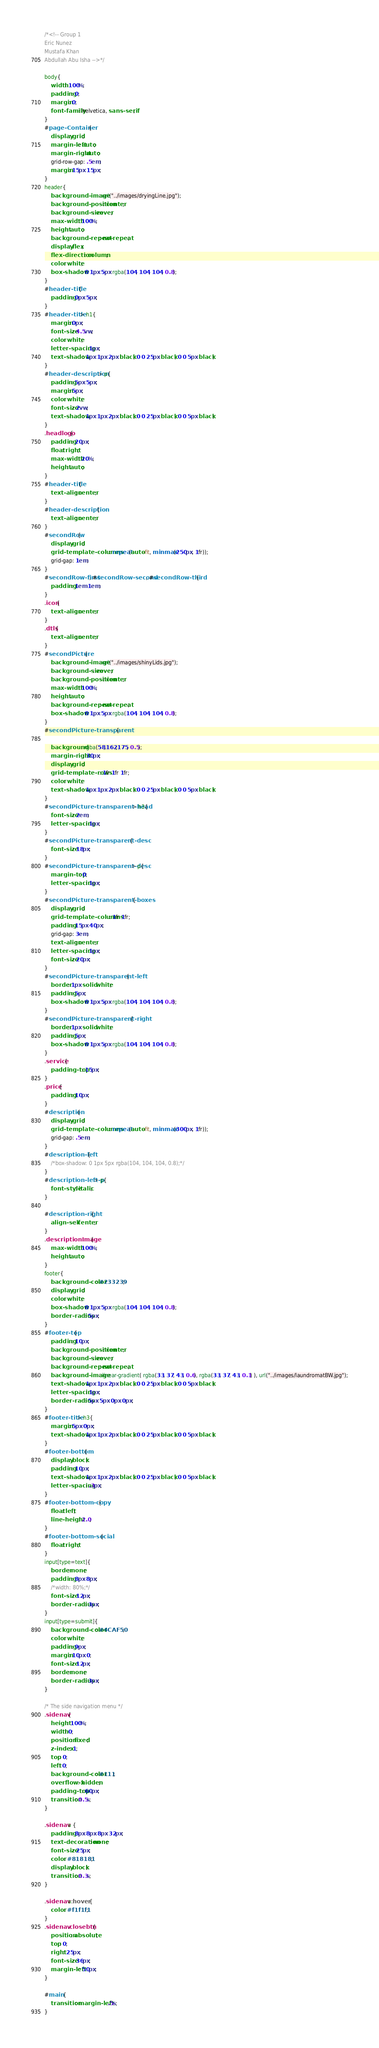<code> <loc_0><loc_0><loc_500><loc_500><_CSS_>/*<!-- Group 1
Eric Nunez
Mustafa Khan
Abdullah Abu Isha -->*/

body{
	width: 100%;
	padding: 0;
	margin: 0;
	font-family: helvetica, sans-serif;
}
#page-Container{
	display: grid;
	margin-left: auto;
	margin-right: auto;
	grid-row-gap: .5em;
	margin: 15px 15px;
}
header{
	background-image: url("../images/dryingLine.jpg");
	background-position: center;
	background-size: cover;
	max-width: 100%;
	height: auto;
	background-repeat: no-repeat;
	display: flex;
	flex-direction: column;
	color: white;
	box-shadow: 0 1px 5px rgba(104, 104, 104, 0.8);
}
#header-title{
	padding: 0px 5px;
}
#header-title > h1{
	margin: 0px;
	font-size: 4.5vw;
	color: white;
	letter-spacing: 1px;
    text-shadow: 1px 1px 2px black, 0 0 25px black, 0 0 5px black;
}
#header-description > p{
	padding: 5px 5px;
	margin: 5px;
	color: white;
	font-size: 2vw;
    text-shadow: 1px 1px 2px black, 0 0 25px black, 0 0 5px black;
}
.headlogo{
	padding: 20px;
	float: right;
	max-width: 20%;
    height: auto;
}
#header-title{
	text-align: center;
}
#header-description{
	text-align: center;
}
#secondRow{
	display: grid;
	grid-template-columns: repeat(auto-fit, minmax(250px, 1fr));
	grid-gap: 1em;
}
#secondRow-first, #secondRow-second, #secondRow-third{
	padding: 1em 1em;
}
.icon{
	text-align: center;
}
.dtls{
	text-align: center;
}
#secondPicture{
	background-image: url("../images/shinyLids.jpg");
	background-size: cover;
	background-position: center;
	max-width: 100%;
	height: auto;
	background-repeat: no-repeat;
	box-shadow: 0 1px 5px rgba(104, 104, 104, 0.8);
}
#secondPicture-transparent{

	background: rgba(58,162,175, 0.5);
	margin-right: 30px;
	display: grid;
	grid-template-rows: 1fr 1fr 1fr;
	color: white;
	text-shadow: 1px 1px 2px black, 0 0 25px black, 0 0 5px black;
}
#secondPicture-transparent-head > h3{
	font-size: 2em;
	letter-spacing: 1px;
}
#secondPicture-transparent-desc{
	font-size: 18px;
}
#secondPicture-transparent-desc > p{
	margin-top: 0;
	letter-spacing: 1px;
}
#secondPicture-transparent-boxes{
	display: grid;
	grid-template-columns: 1fr 1fr;
	padding: 15px 40px;
	grid-gap: 3em;
	text-align: center;
	letter-spacing: 1px;
	font-size: 20px;
}
#secondPicture-transparent-left{
	border: 1px solid white;
	padding: 5px;
	box-shadow: 0 1px 5px rgba(104, 104, 104, 0.8);
}
#secondPicture-transparent-right{
	border: 1px solid white;
	padding: 5px;
	box-shadow: 0 1px 5px rgba(104, 104, 104, 0.8);
}
.service{
	padding-top: 15px;
}
.price{
	padding: 10px;
}
#description{
	display: grid;
	grid-template-columns: repeat(auto-fit, minmax(300px, 1fr));
	grid-gap: .5em;
}
#description-left{
	/*box-shadow: 0 1px 5px rgba(104, 104, 104, 0.8);*/
}
#description-left-p > p{
	font-style: italic;
}

#description-right{
	align-self: center;
}
.descriptionImage{
	max-width: 100%;
    height: auto;
}
footer{
	background-color: #233239;
	display: grid;
	color: white;
	box-shadow: 0 1px 5px rgba(104, 104, 104, 0.8);
	border-radius: 5px;
}
#footer-top{
	padding: 10px;
	background-position: center;
	background-size: cover;
	background-repeat: no-repeat;
	background-image: linear-gradient( rgba(33, 37, 43, 0.6), rgba(33, 37, 43, 0.1) ), url("../images/laundromatBW.jpg");
	text-shadow: 1px 1px 2px black, 0 0 25px black, 0 0 5px black;
	letter-spacing: 1px;
	border-radius: 5px 5px 0px 0px;
}
#footer-title > h3{
	margin: 5px 0px;
	text-shadow: 1px 1px 2px black, 0 0 25px black, 0 0 5px black;
}
#footer-bottom{
	display: block;
	padding: 10px;
	text-shadow: 1px 1px 2px black, 0 0 25px black, 0 0 5px black;
	letter-spacing: .3px;
}
#footer-bottom-copy{
	float: left;
	line-height: 2.0;
}
#footer-bottom-social{
	float: right;
}
input[type=text]{
	border: none;
	padding: 8px 8px;
	/*width: 80%;*/
	font-size: 12px;
	border-radius: 3px;
}
input[type=submit]{
	background-color: #4CAF50;
	color: white;
	padding: 9px;
	margin: 10px 0;
	font-size: 12px;
	border: none;
	border-radius: 3px;
}

/* The side navigation menu */
.sidenav {
    height: 100%; 
    width: 0; 
    position: fixed; 
    z-index: 1; 
    top: 0; 
    left: 0;
    background-color: #111; 
    overflow-x: hidden; 
    padding-top: 60px; 
    transition: 0.5s; 
}

.sidenav a {
    padding: 8px 8px 8px 32px;
    text-decoration: none;
    font-size: 25px;
    color: #818181;
    display: block;
    transition: 0.3s;
}

.sidenav a:hover {
    color: #f1f1f1;
}
.sidenav .closebtn {
    position: absolute;
    top: 0;
    right: 25px;
    font-size: 36px;
    margin-left: 50px;
}

#main {
    transition: margin-left .5s;
}
</code> 